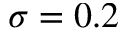<formula> <loc_0><loc_0><loc_500><loc_500>\sigma = 0 . 2</formula> 